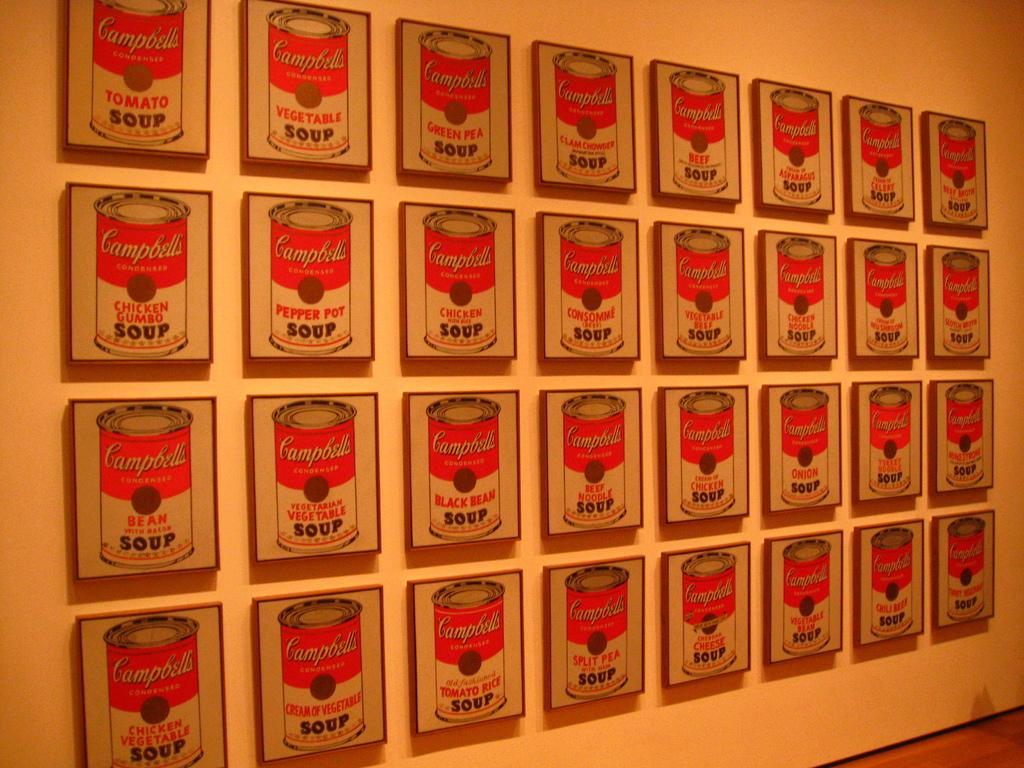<image>
Present a compact description of the photo's key features. 32 images of different flavors of Campbell's Soup are displayed next to each other. 